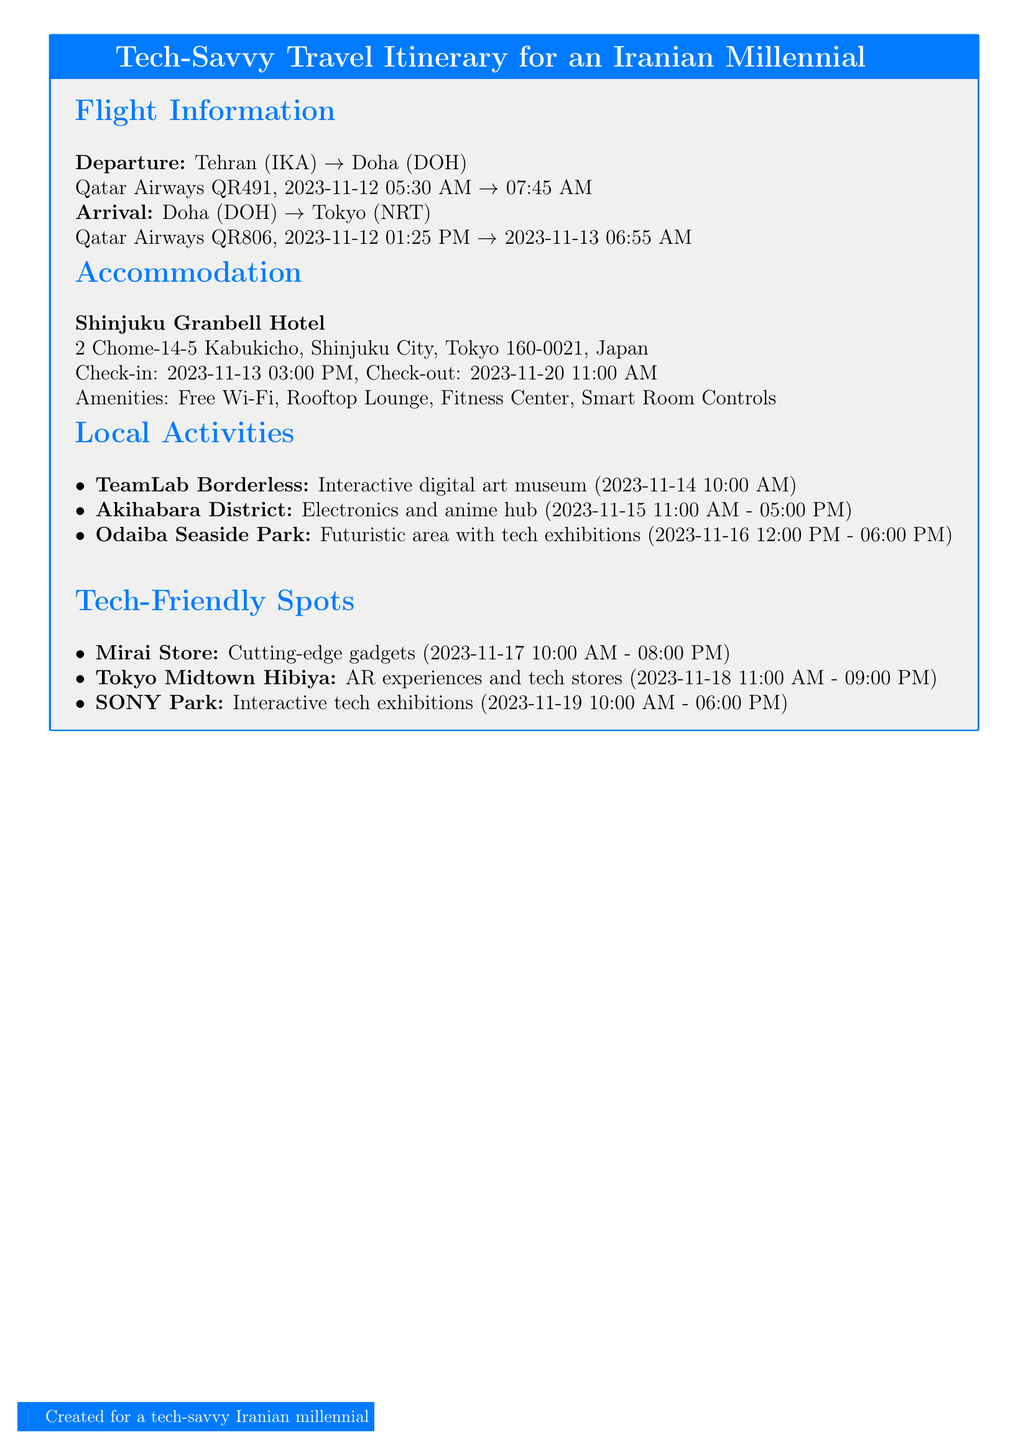What is the flight number from Tehran to Doha? The flight number from Tehran to Doha is mentioned under Flight Information.
Answer: QR491 What is the check-in time at Shinjuku Granbell Hotel? The check-in time is specified in the Accommodation section of the document.
Answer: 03:00 PM When is the visit to TeamLab Borderless scheduled? The date and time for the visit to TeamLab Borderless is listed under Local Activities.
Answer: 2023-11-14 10:00 AM Which tech-friendly spot opens at 10:00 AM on November 17? This information is found in the Tech-Friendly Spots section, detailing its schedule.
Answer: Mirai Store How long is the stay at the Shinjuku Granbell Hotel? To find the duration, consider the check-in and check-out dates provided in the document.
Answer: 7 days What activity is scheduled on November 15? The specific activity planned is listed in the Local Activities section by date.
Answer: Akihabara District Which flight departs from Doha to Tokyo? The flight details from Doha to Tokyo are stated in the Flight Information section.
Answer: QR806 What is one amenity available at the hotel? Amenities are listed under the Accommodation section that highlights hotel features.
Answer: Free Wi-Fi 